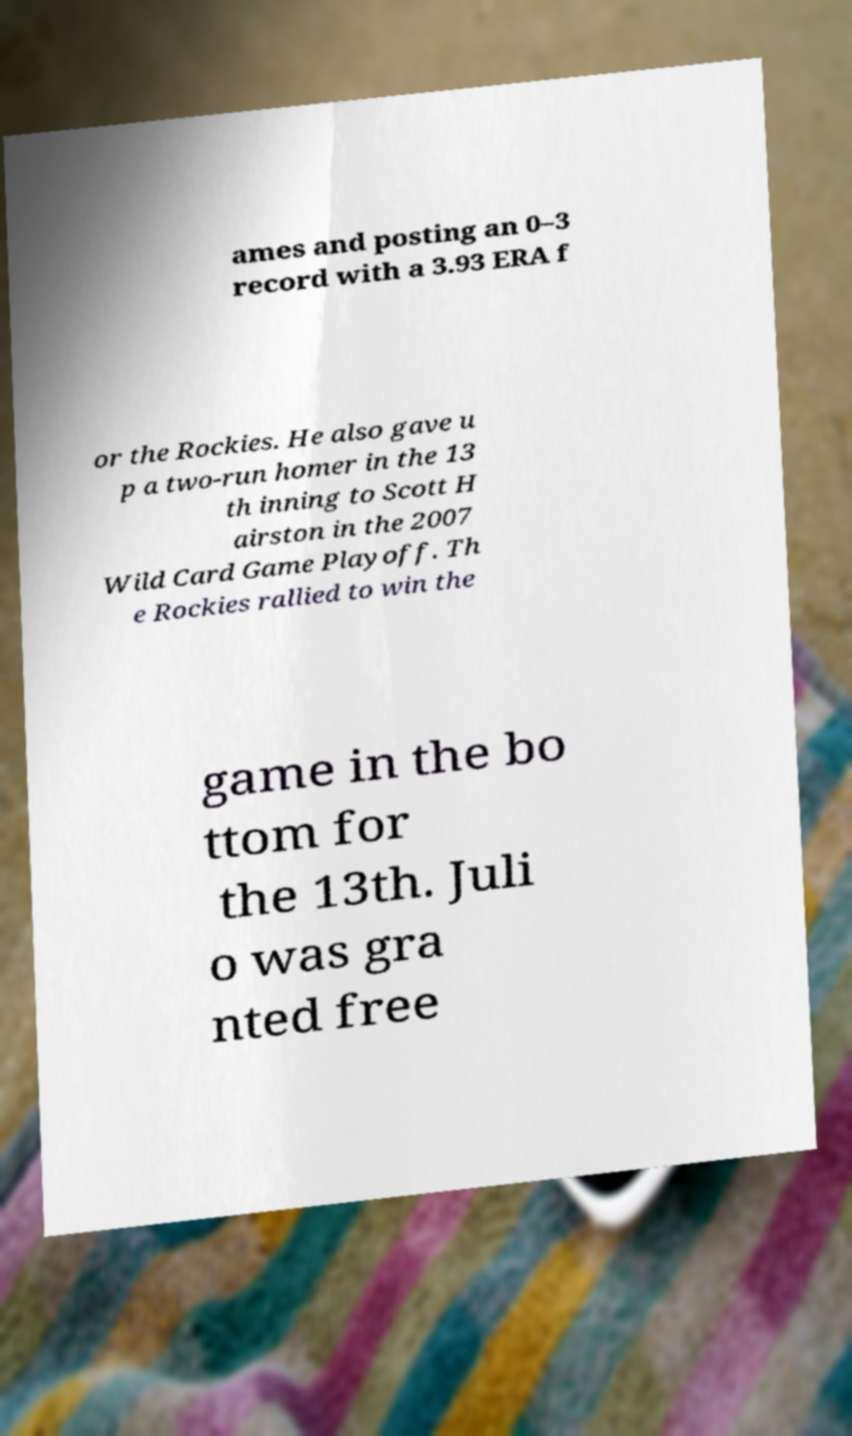There's text embedded in this image that I need extracted. Can you transcribe it verbatim? ames and posting an 0–3 record with a 3.93 ERA f or the Rockies. He also gave u p a two-run homer in the 13 th inning to Scott H airston in the 2007 Wild Card Game Playoff. Th e Rockies rallied to win the game in the bo ttom for the 13th. Juli o was gra nted free 